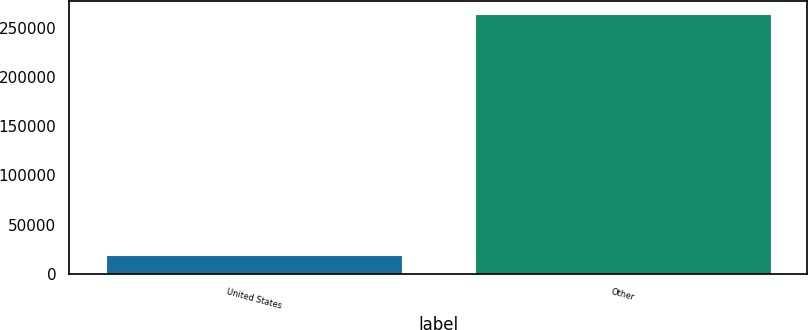<chart> <loc_0><loc_0><loc_500><loc_500><bar_chart><fcel>United States<fcel>Other<nl><fcel>19550<fcel>264196<nl></chart> 